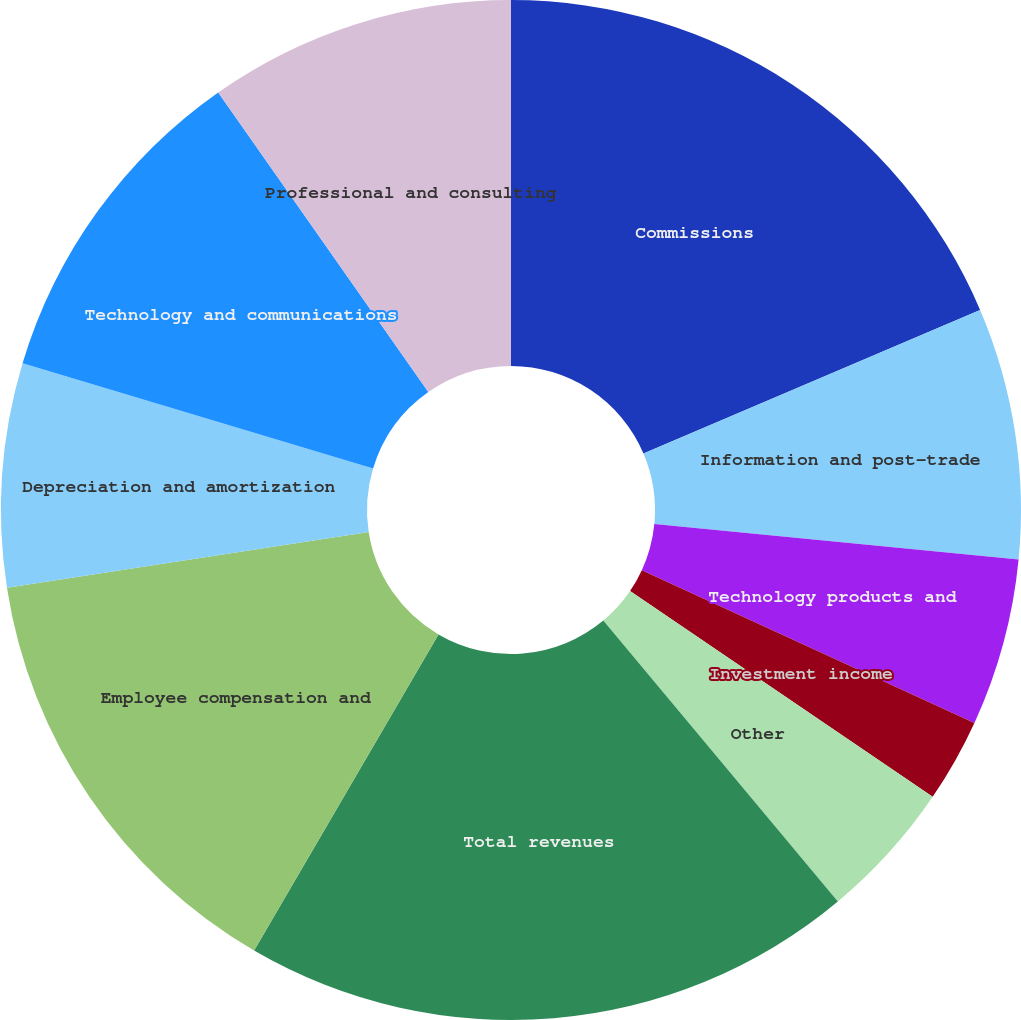<chart> <loc_0><loc_0><loc_500><loc_500><pie_chart><fcel>Commissions<fcel>Information and post-trade<fcel>Technology products and<fcel>Investment income<fcel>Other<fcel>Total revenues<fcel>Employee compensation and<fcel>Depreciation and amortization<fcel>Technology and communications<fcel>Professional and consulting<nl><fcel>18.58%<fcel>7.96%<fcel>5.31%<fcel>2.65%<fcel>4.42%<fcel>19.47%<fcel>14.16%<fcel>7.08%<fcel>10.62%<fcel>9.73%<nl></chart> 